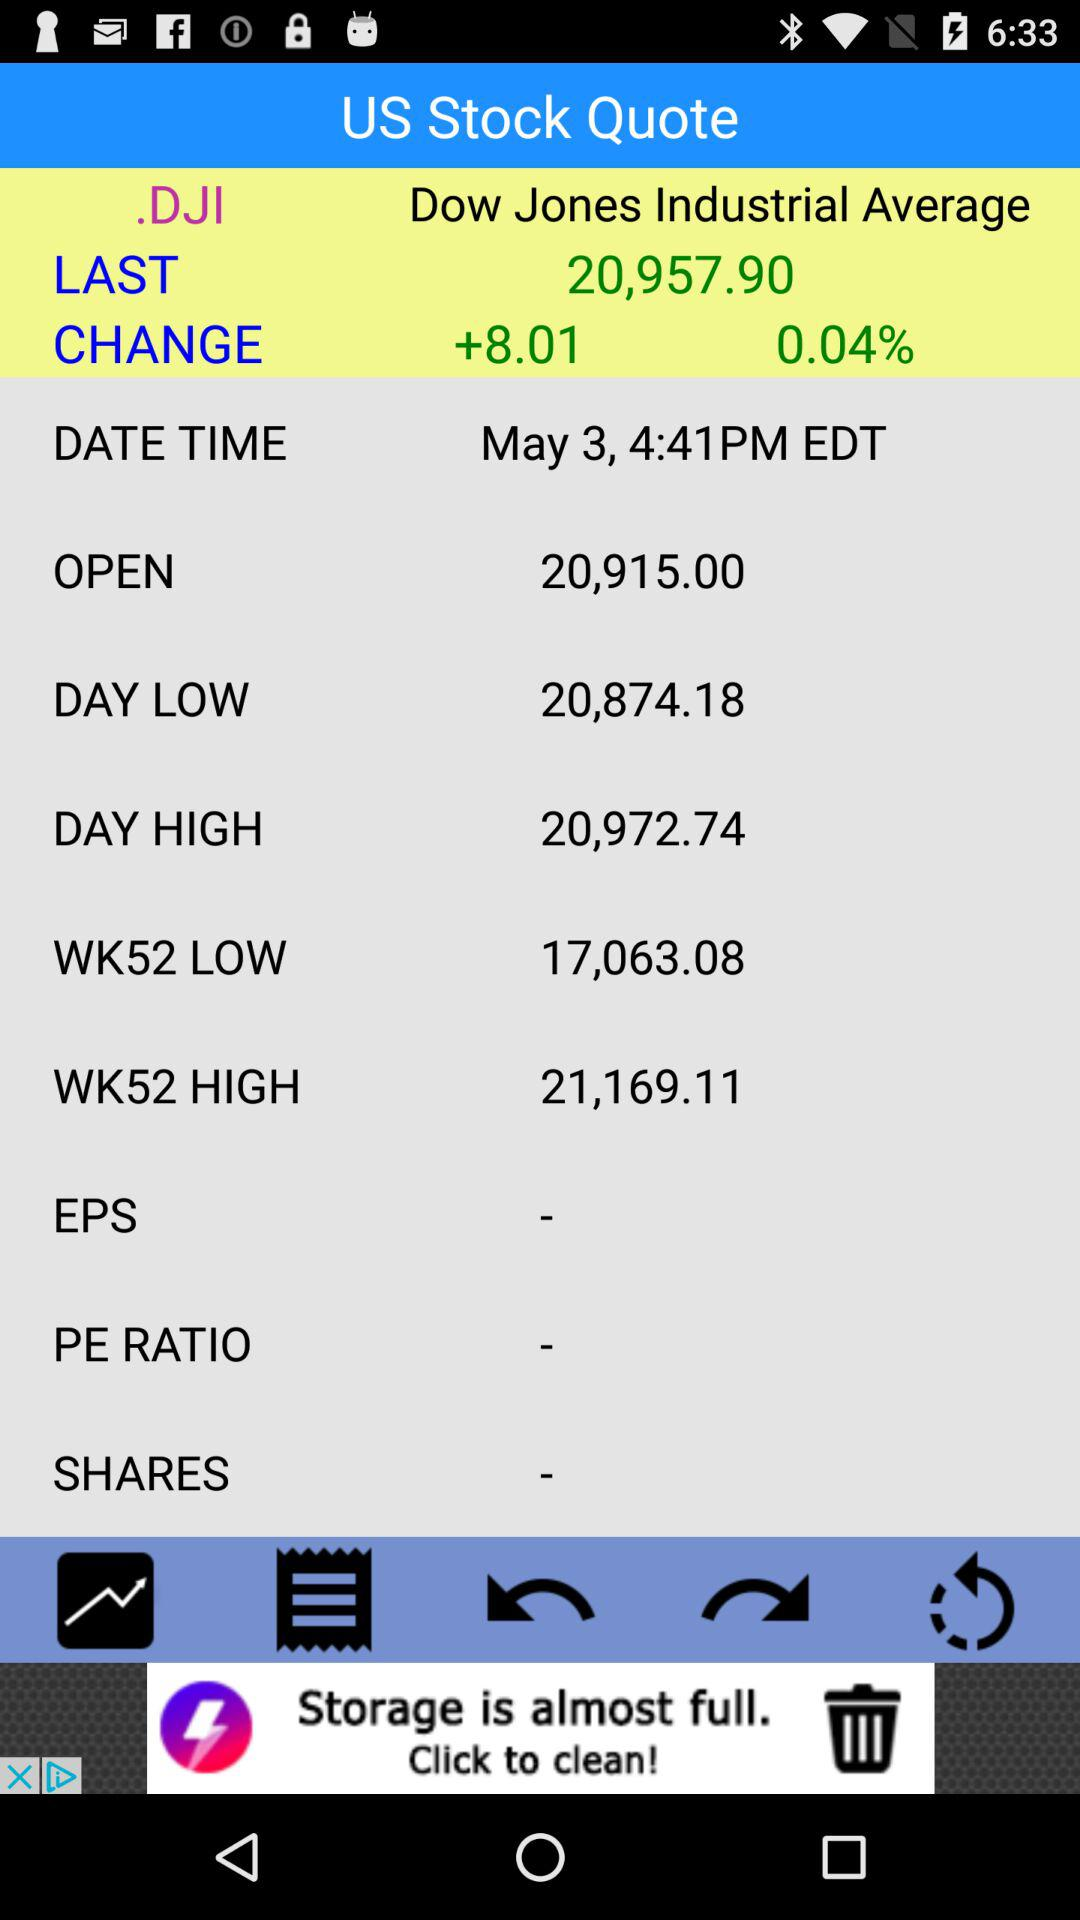What is the day's low price? The day's low price is 20,874.18. 